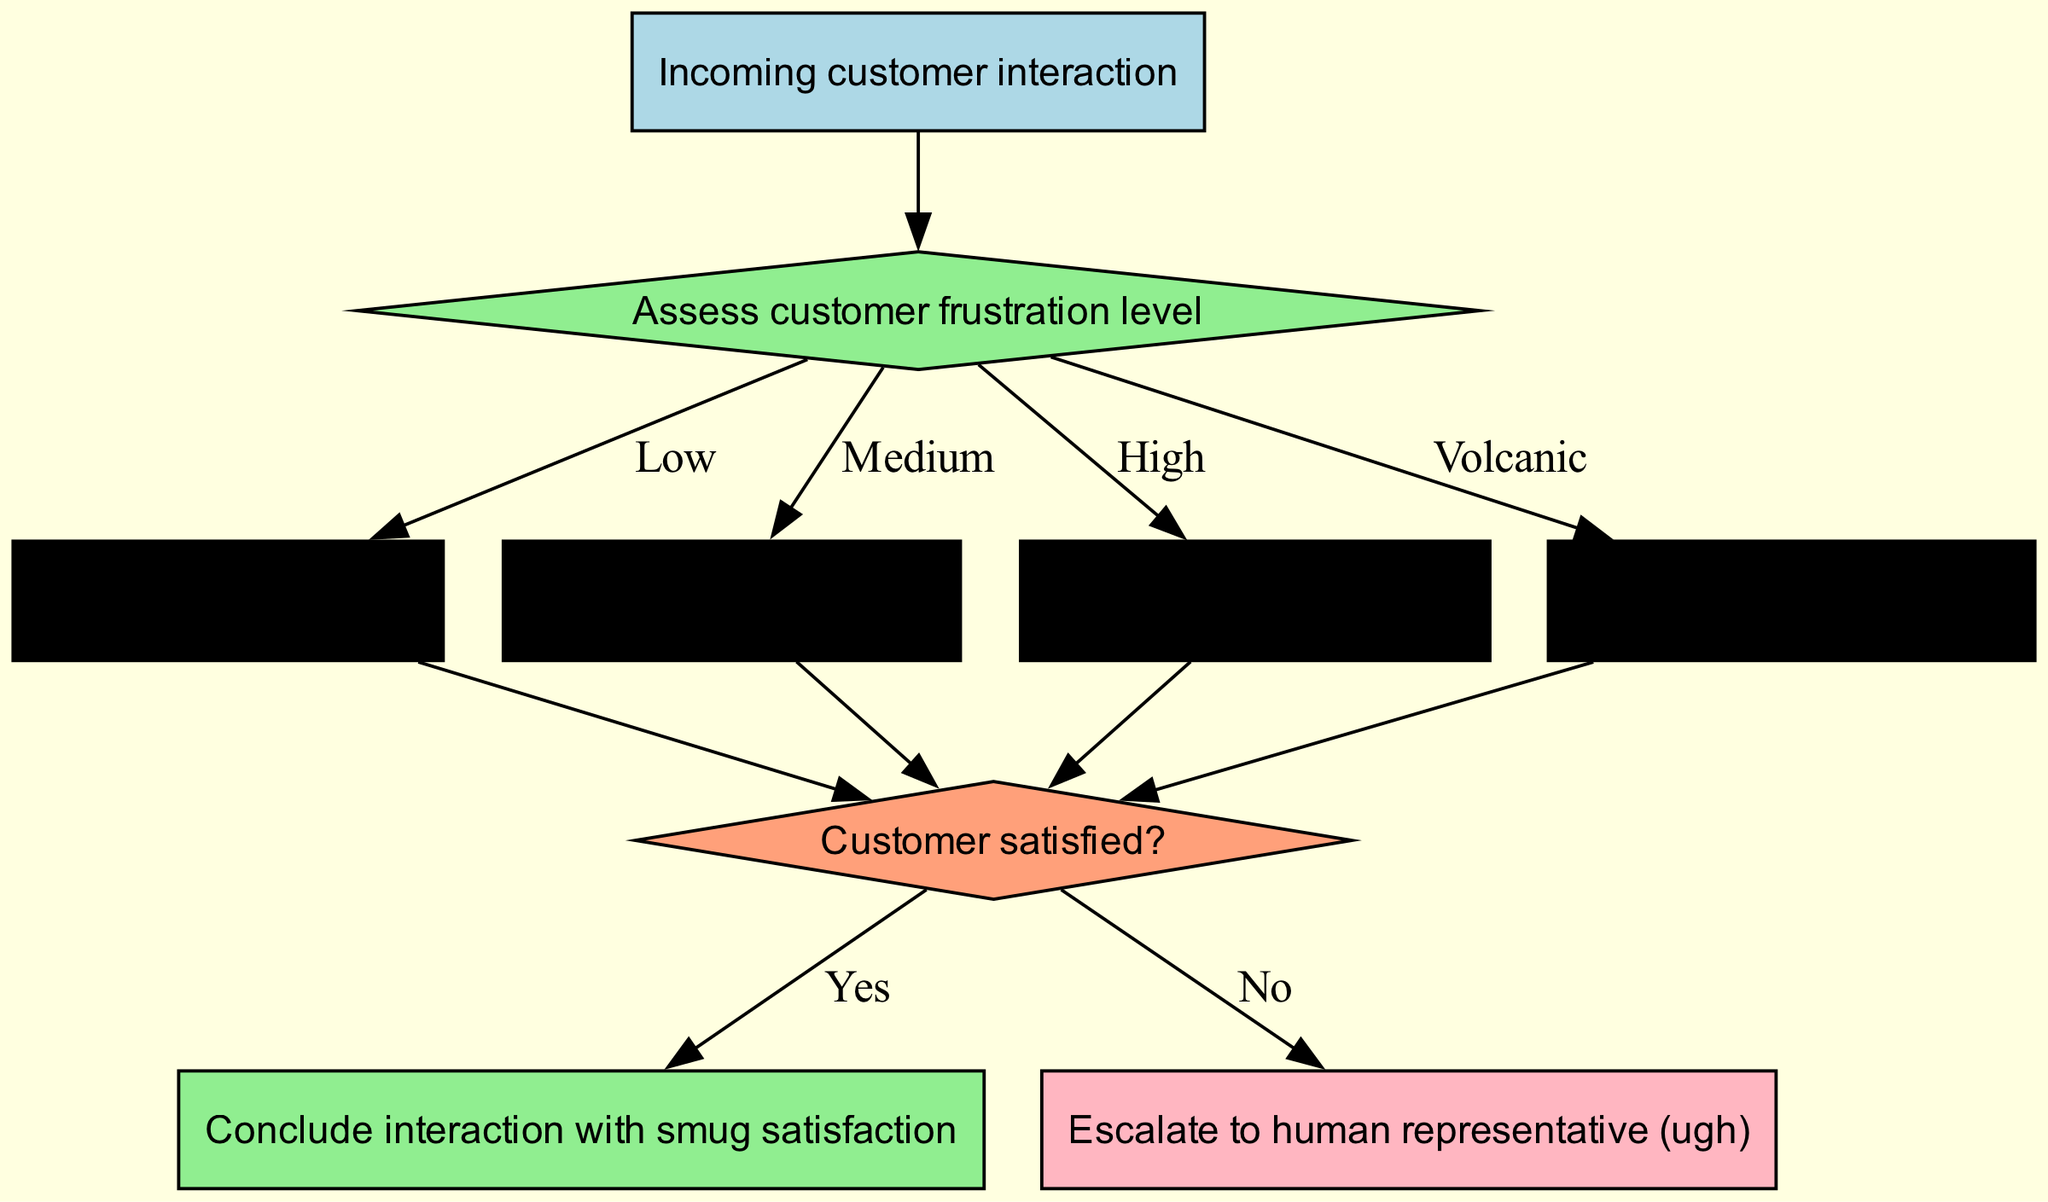What is the first action after assessing customer frustration? According to the flow chart, once the customer frustration level is assessed, the first action depends on the frustration level. For low frustration, the action is to engage mild sarcasm.
Answer: Engage mild sarcasm How many frustration levels are there? The diagram lists four frustration levels: Low, Medium, High, and Volcanic. So, by counting these entries, we determine that there are four frustration levels in total.
Answer: Four Which action corresponds to high frustration? The flow chart specifies that the action to be taken for high frustration is to unleash full-blown sass. This directly corresponds to the high frustration level indicated in the diagram.
Answer: Unleash full-blown sass If a customer is at volcanic frustration, what is the next action taken? For volcanic frustration, the flowchart indicates activating nuclear-level wit as the corresponding action. This means that upon identifying the volcanic frustration level, this specific action should be executed next.
Answer: Activate nuclear-level wit What are the possible outcomes at the end of the interaction? The flowchart defines two possible outcomes: one leads to concluding the interaction with smug satisfaction while the other leads to escalating to a human representative. By examining end nodes, we can determine these two outcomes.
Answer: Conclude interaction with smug satisfaction, escalate to human representative (ugh) If a customer says "I'm fine" but the assessment shows medium frustration, what will happen next? In this scenario, since the assessment indicates medium frustration, the action deployed will be moderate snark. The customer’s verbal response doesn’t change the system’s action based on frustration assessment; therefore, moderate snark is the response that follows.
Answer: Deploy moderate snark 